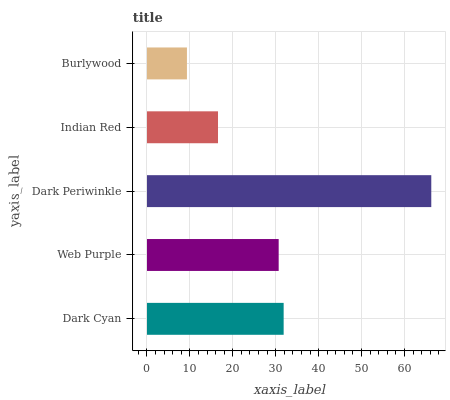Is Burlywood the minimum?
Answer yes or no. Yes. Is Dark Periwinkle the maximum?
Answer yes or no. Yes. Is Web Purple the minimum?
Answer yes or no. No. Is Web Purple the maximum?
Answer yes or no. No. Is Dark Cyan greater than Web Purple?
Answer yes or no. Yes. Is Web Purple less than Dark Cyan?
Answer yes or no. Yes. Is Web Purple greater than Dark Cyan?
Answer yes or no. No. Is Dark Cyan less than Web Purple?
Answer yes or no. No. Is Web Purple the high median?
Answer yes or no. Yes. Is Web Purple the low median?
Answer yes or no. Yes. Is Dark Cyan the high median?
Answer yes or no. No. Is Burlywood the low median?
Answer yes or no. No. 